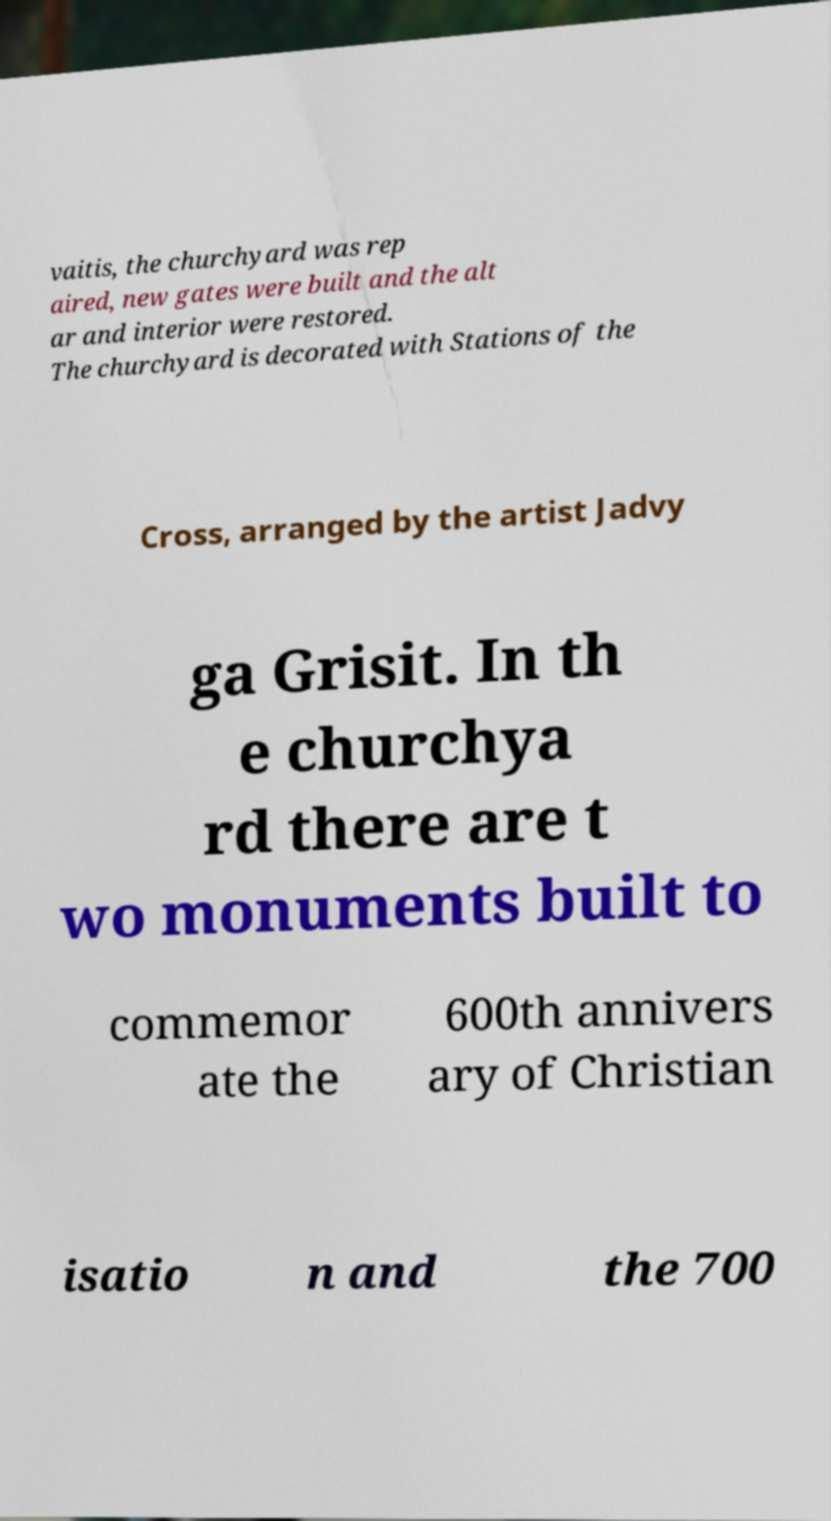There's text embedded in this image that I need extracted. Can you transcribe it verbatim? vaitis, the churchyard was rep aired, new gates were built and the alt ar and interior were restored. The churchyard is decorated with Stations of the Cross, arranged by the artist Jadvy ga Grisit. In th e churchya rd there are t wo monuments built to commemor ate the 600th annivers ary of Christian isatio n and the 700 